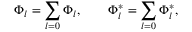Convert formula to latex. <formula><loc_0><loc_0><loc_500><loc_500>\Phi _ { l } = \sum _ { l = 0 } \Phi _ { l } , \quad \Phi _ { l } ^ { \ast } = \sum _ { l = 0 } \Phi _ { l } ^ { \ast } ,</formula> 